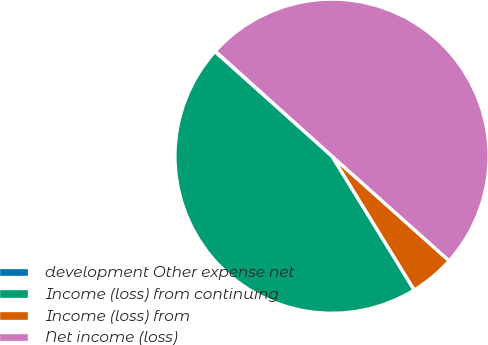Convert chart. <chart><loc_0><loc_0><loc_500><loc_500><pie_chart><fcel>development Other expense net<fcel>Income (loss) from continuing<fcel>Income (loss) from<fcel>Net income (loss)<nl><fcel>0.06%<fcel>45.37%<fcel>4.63%<fcel>49.94%<nl></chart> 